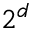Convert formula to latex. <formula><loc_0><loc_0><loc_500><loc_500>2 ^ { d }</formula> 